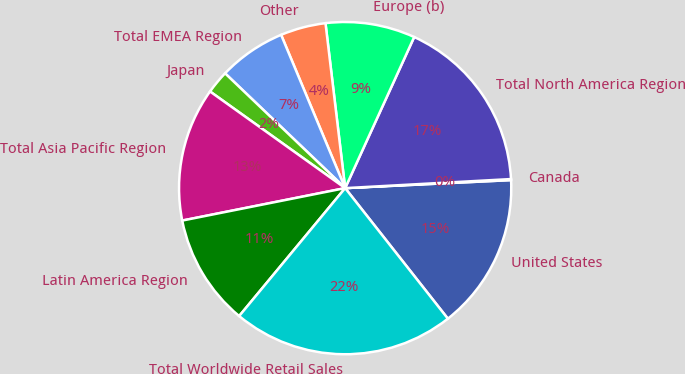<chart> <loc_0><loc_0><loc_500><loc_500><pie_chart><fcel>United States<fcel>Canada<fcel>Total North America Region<fcel>Europe (b)<fcel>Other<fcel>Total EMEA Region<fcel>Japan<fcel>Total Asia Pacific Region<fcel>Latin America Region<fcel>Total Worldwide Retail Sales<nl><fcel>15.16%<fcel>0.1%<fcel>17.31%<fcel>8.71%<fcel>4.41%<fcel>6.56%<fcel>2.26%<fcel>13.01%<fcel>10.86%<fcel>21.62%<nl></chart> 